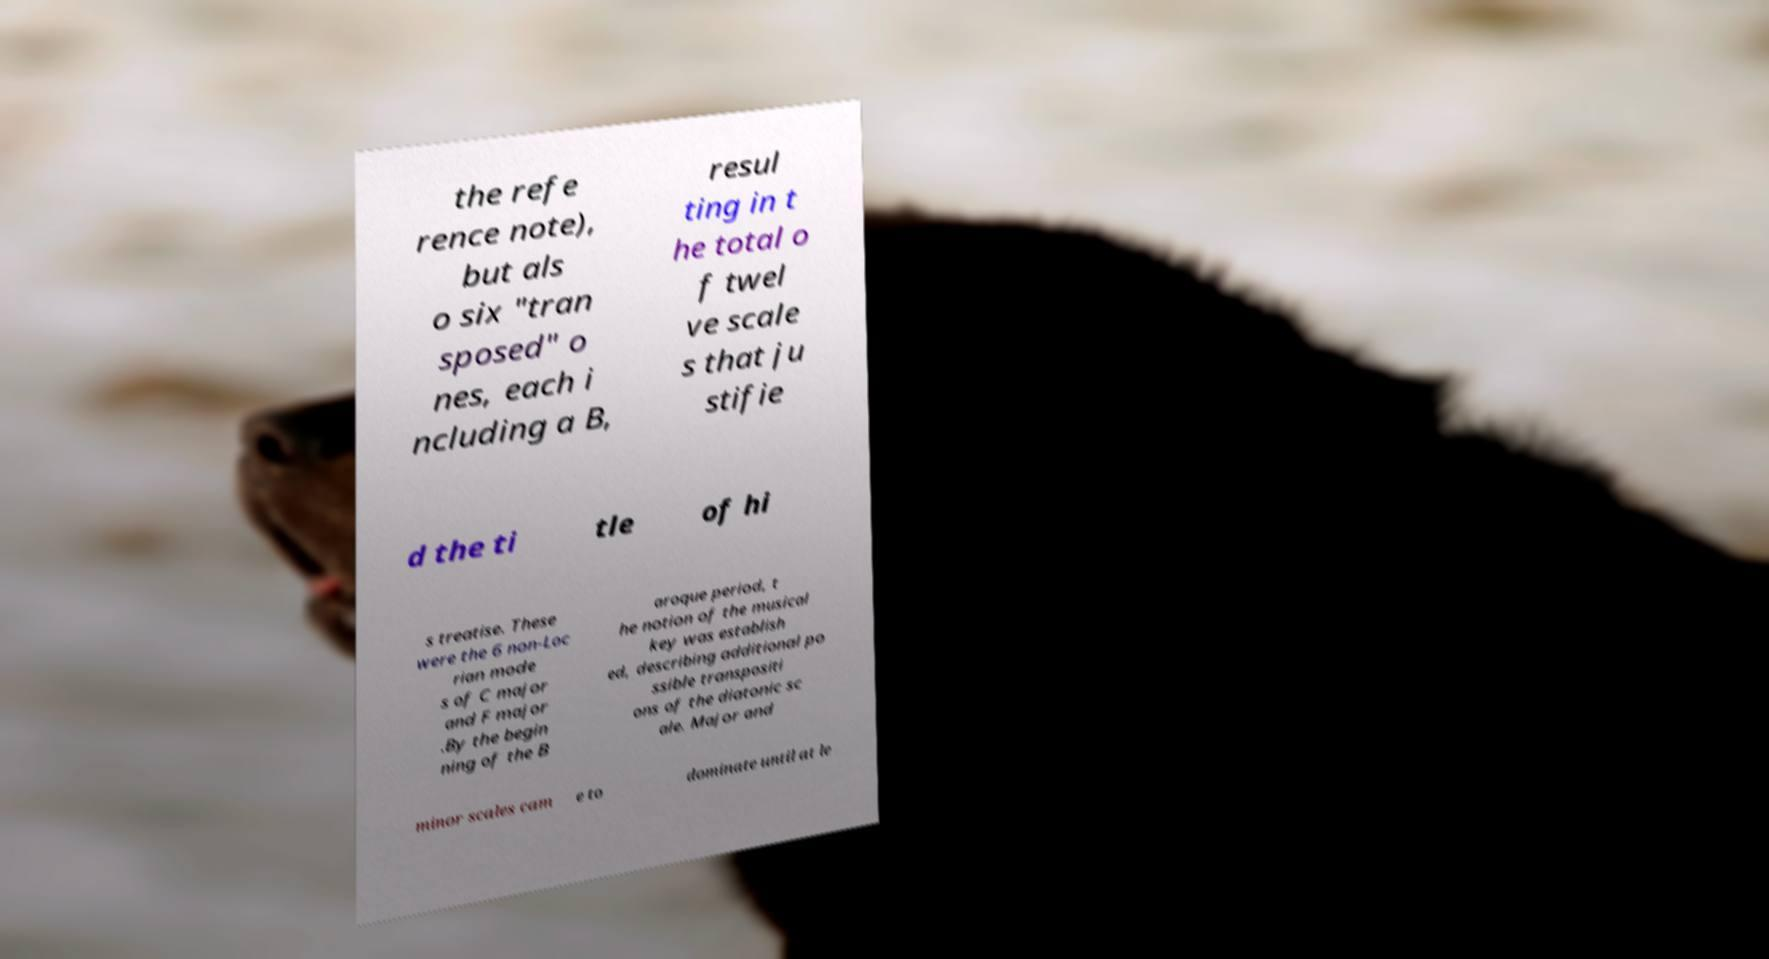Could you extract and type out the text from this image? the refe rence note), but als o six "tran sposed" o nes, each i ncluding a B, resul ting in t he total o f twel ve scale s that ju stifie d the ti tle of hi s treatise. These were the 6 non-Loc rian mode s of C major and F major .By the begin ning of the B aroque period, t he notion of the musical key was establish ed, describing additional po ssible transpositi ons of the diatonic sc ale. Major and minor scales cam e to dominate until at le 